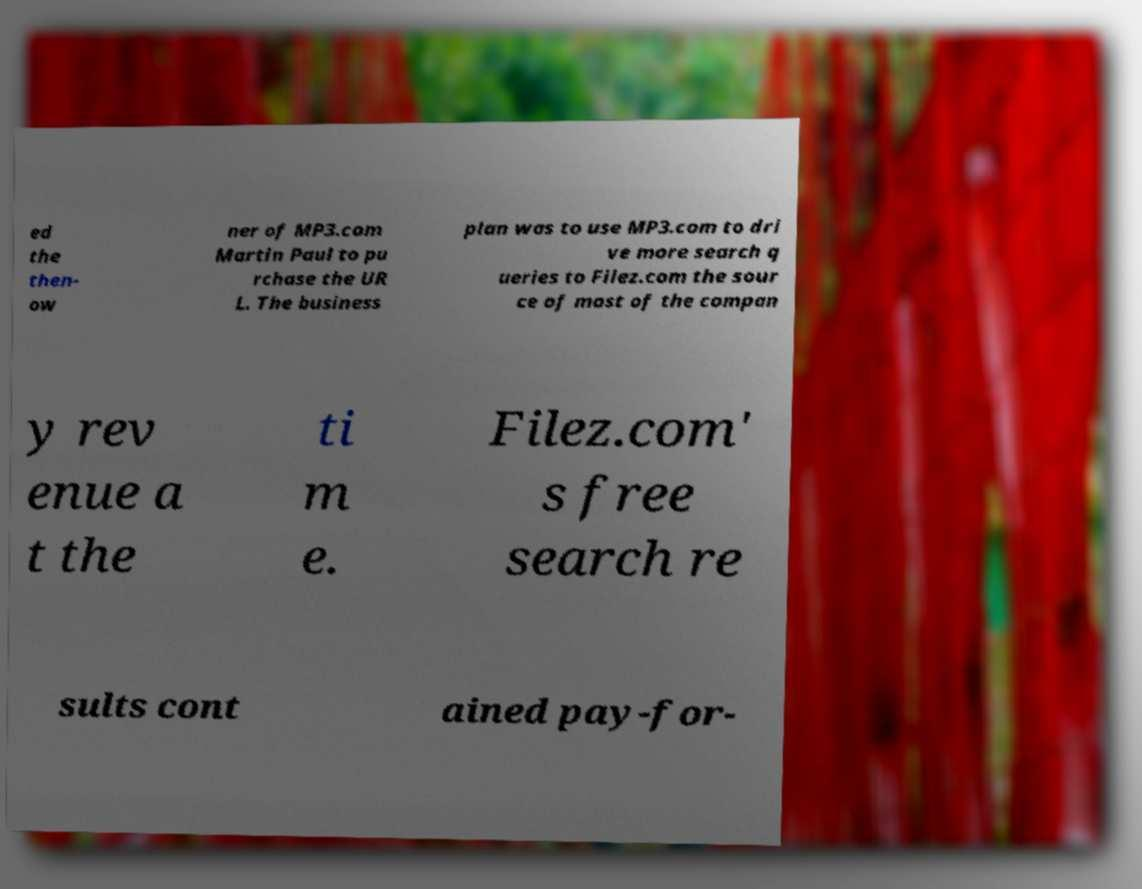I need the written content from this picture converted into text. Can you do that? ed the then- ow ner of MP3.com Martin Paul to pu rchase the UR L. The business plan was to use MP3.com to dri ve more search q ueries to Filez.com the sour ce of most of the compan y rev enue a t the ti m e. Filez.com' s free search re sults cont ained pay-for- 